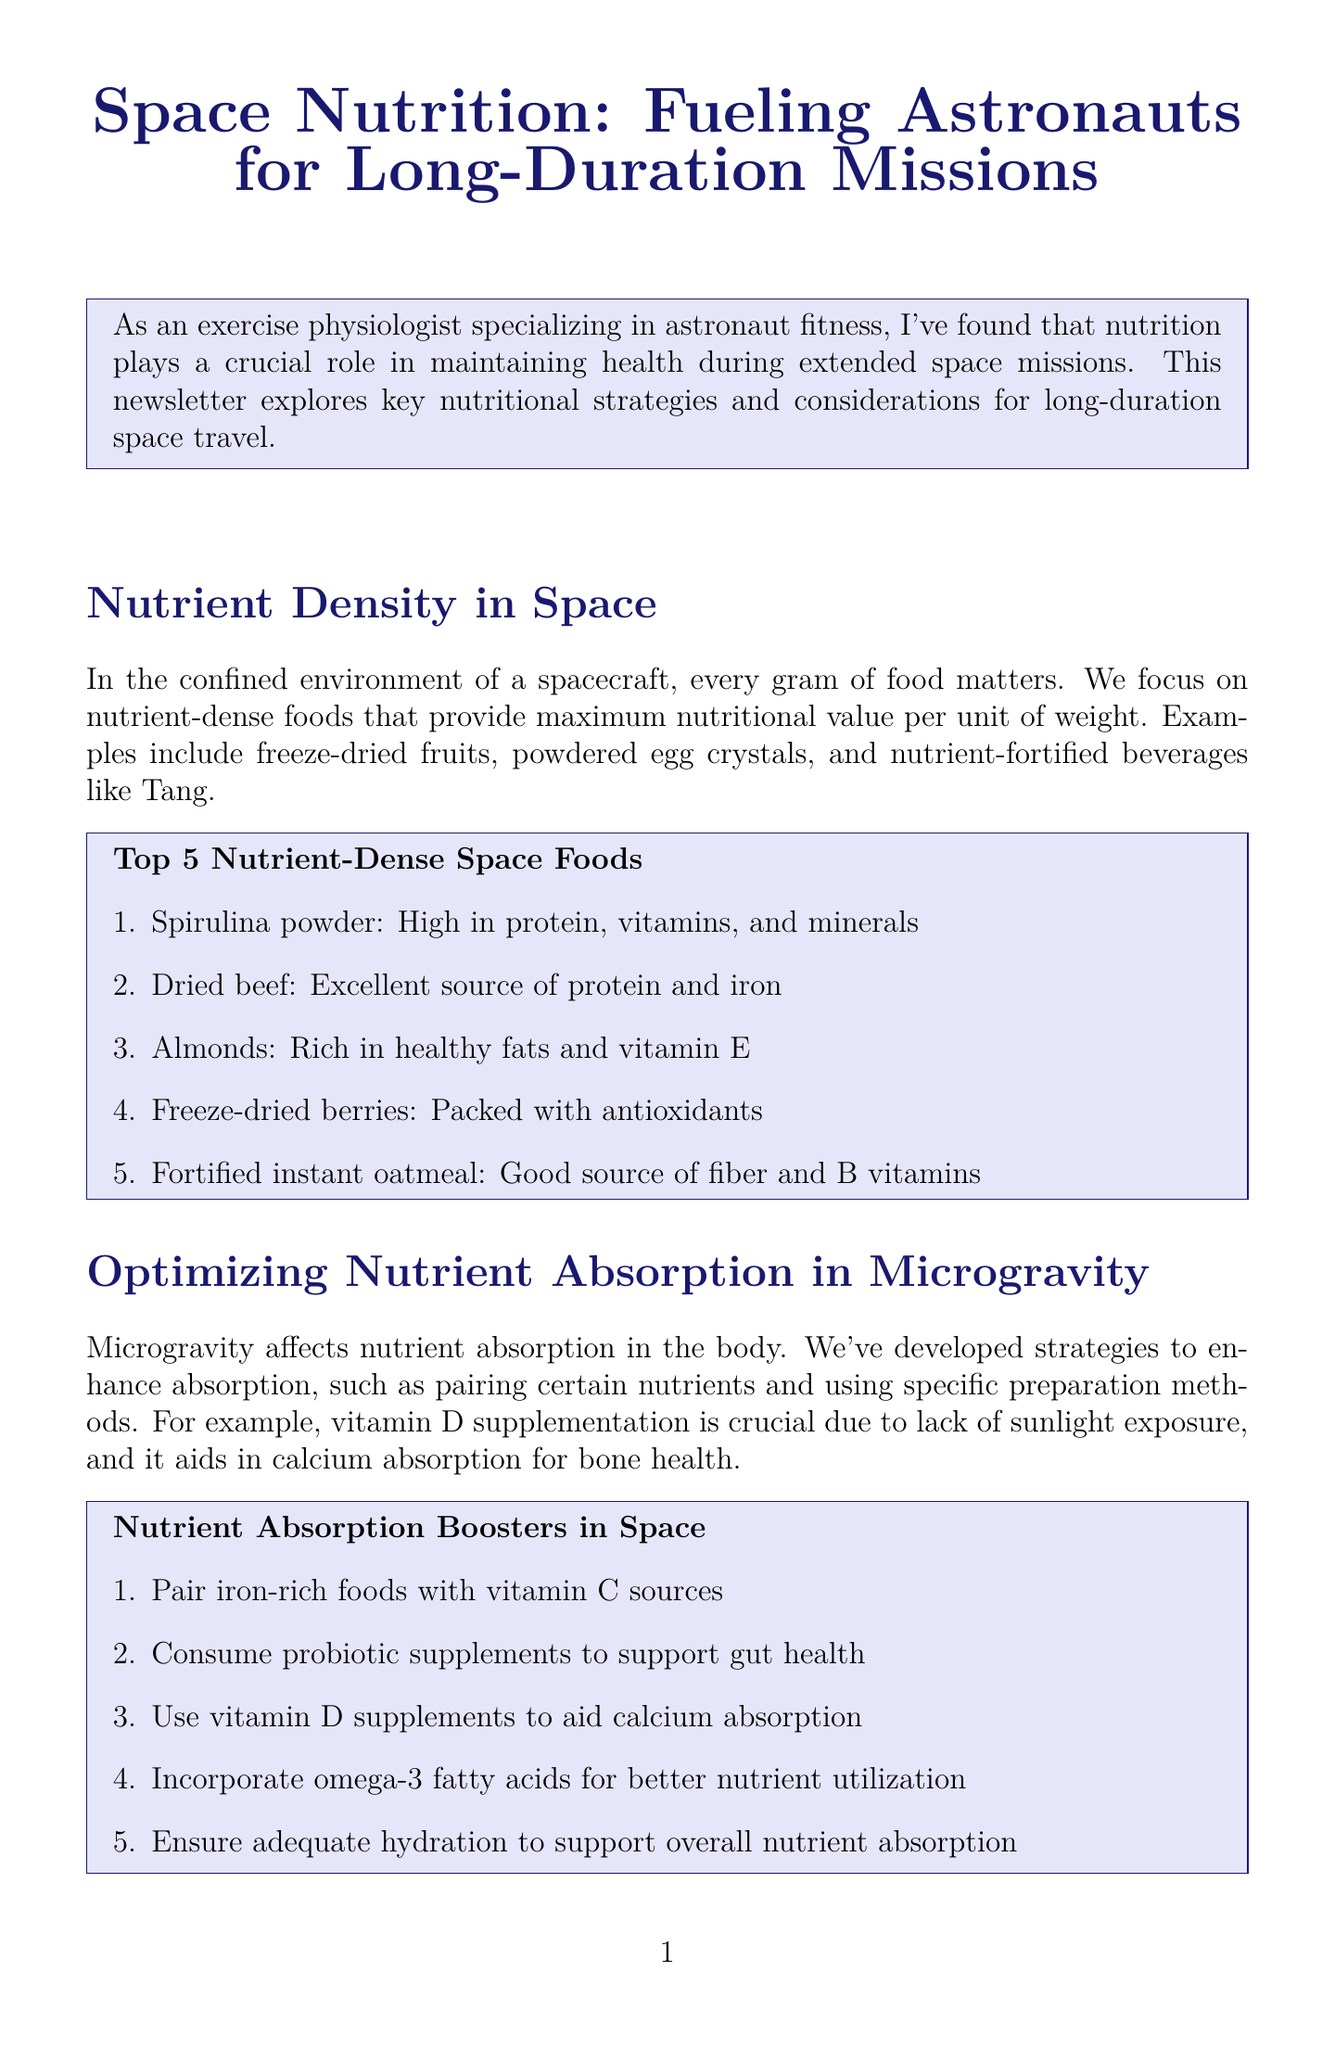What is the newsletter title? The title of the newsletter is specified in the document's title section.
Answer: Space Nutrition: Fueling Astronauts for Long-Duration Missions What is an example of a nutrient-dense food mentioned? The document lists several examples of nutrient-dense foods in the section on nutrient density in space.
Answer: Spirulina powder What does vitamin D supplementation aid in? The document discusses the role of vitamin D supplementation in relation to calcium absorption.
Answer: Calcium absorption What percentage of muscle loss can be reduced according to recent studies? The document provides a statistic about muscle loss reduction from recent studies conducted at NASA.
Answer: 30% What is a recommended source for information on space nutrition? The document mentions where to find more information about space nutrition.
Answer: NASA Human Research Program website Which type of foods help protect against radiation damage? The newsletter discusses types of foods that are beneficial for radiation protection.
Answer: Foods rich in antioxidants How does microgravity affect nutrient absorption? The newsletter explains the impact of microgravity on nutrient absorption within the body.
Answer: It affects nutrient absorption What type of exercise is combined with nutrition strategies to prevent muscle loss? The document highlights the type of exercise used alongside nutrition to mitigate muscle loss.
Answer: Resistive exercise 